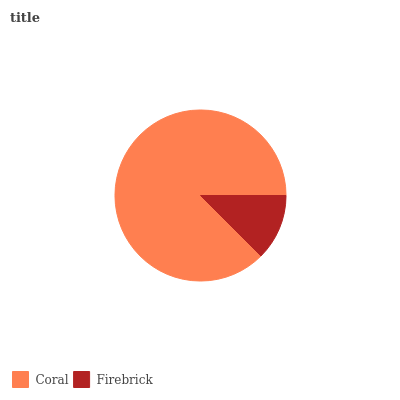Is Firebrick the minimum?
Answer yes or no. Yes. Is Coral the maximum?
Answer yes or no. Yes. Is Firebrick the maximum?
Answer yes or no. No. Is Coral greater than Firebrick?
Answer yes or no. Yes. Is Firebrick less than Coral?
Answer yes or no. Yes. Is Firebrick greater than Coral?
Answer yes or no. No. Is Coral less than Firebrick?
Answer yes or no. No. Is Coral the high median?
Answer yes or no. Yes. Is Firebrick the low median?
Answer yes or no. Yes. Is Firebrick the high median?
Answer yes or no. No. Is Coral the low median?
Answer yes or no. No. 